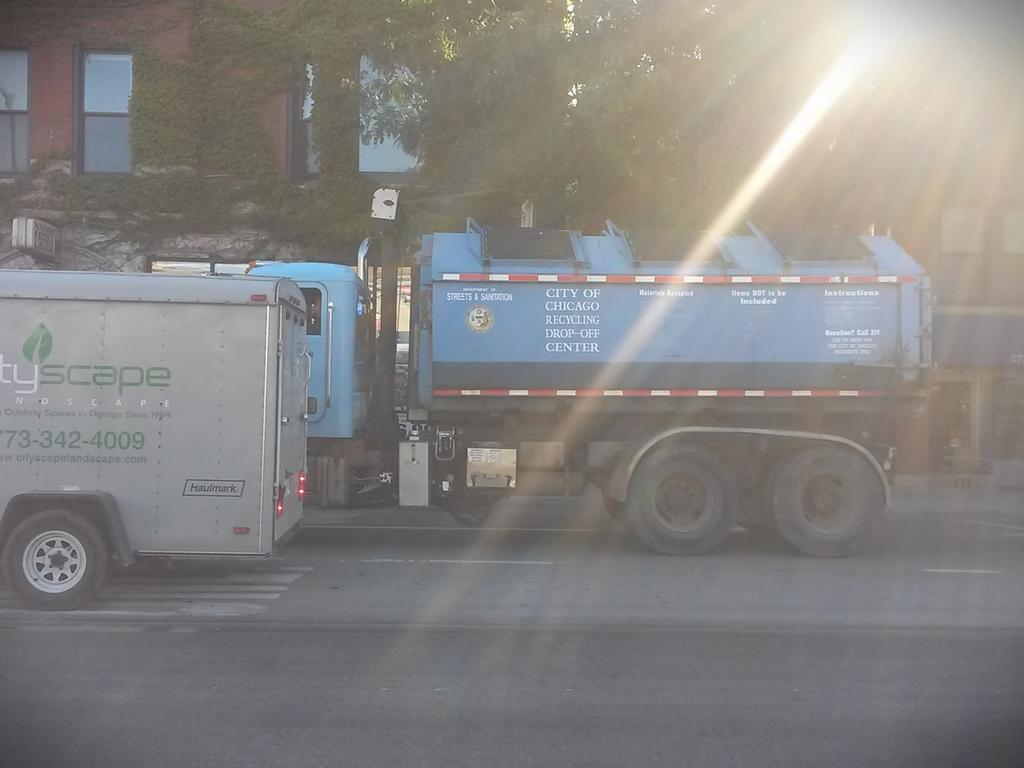What is located in the foreground of the picture? There are vehicles in the foreground of the picture. Where are the vehicles situated? The vehicles are on the road. What can be seen in the background of the picture? There are buildings, a wall, plants, and trees in the background of the picture. Can you describe the position of the sun in the image? The sun is at the top right of the image. What type of throne can be seen in the image? There is no throne present in the image. How many knots are tied in the plants visible in the image? There is no mention of knots in the plants in the image; they are simply visible in the background. 